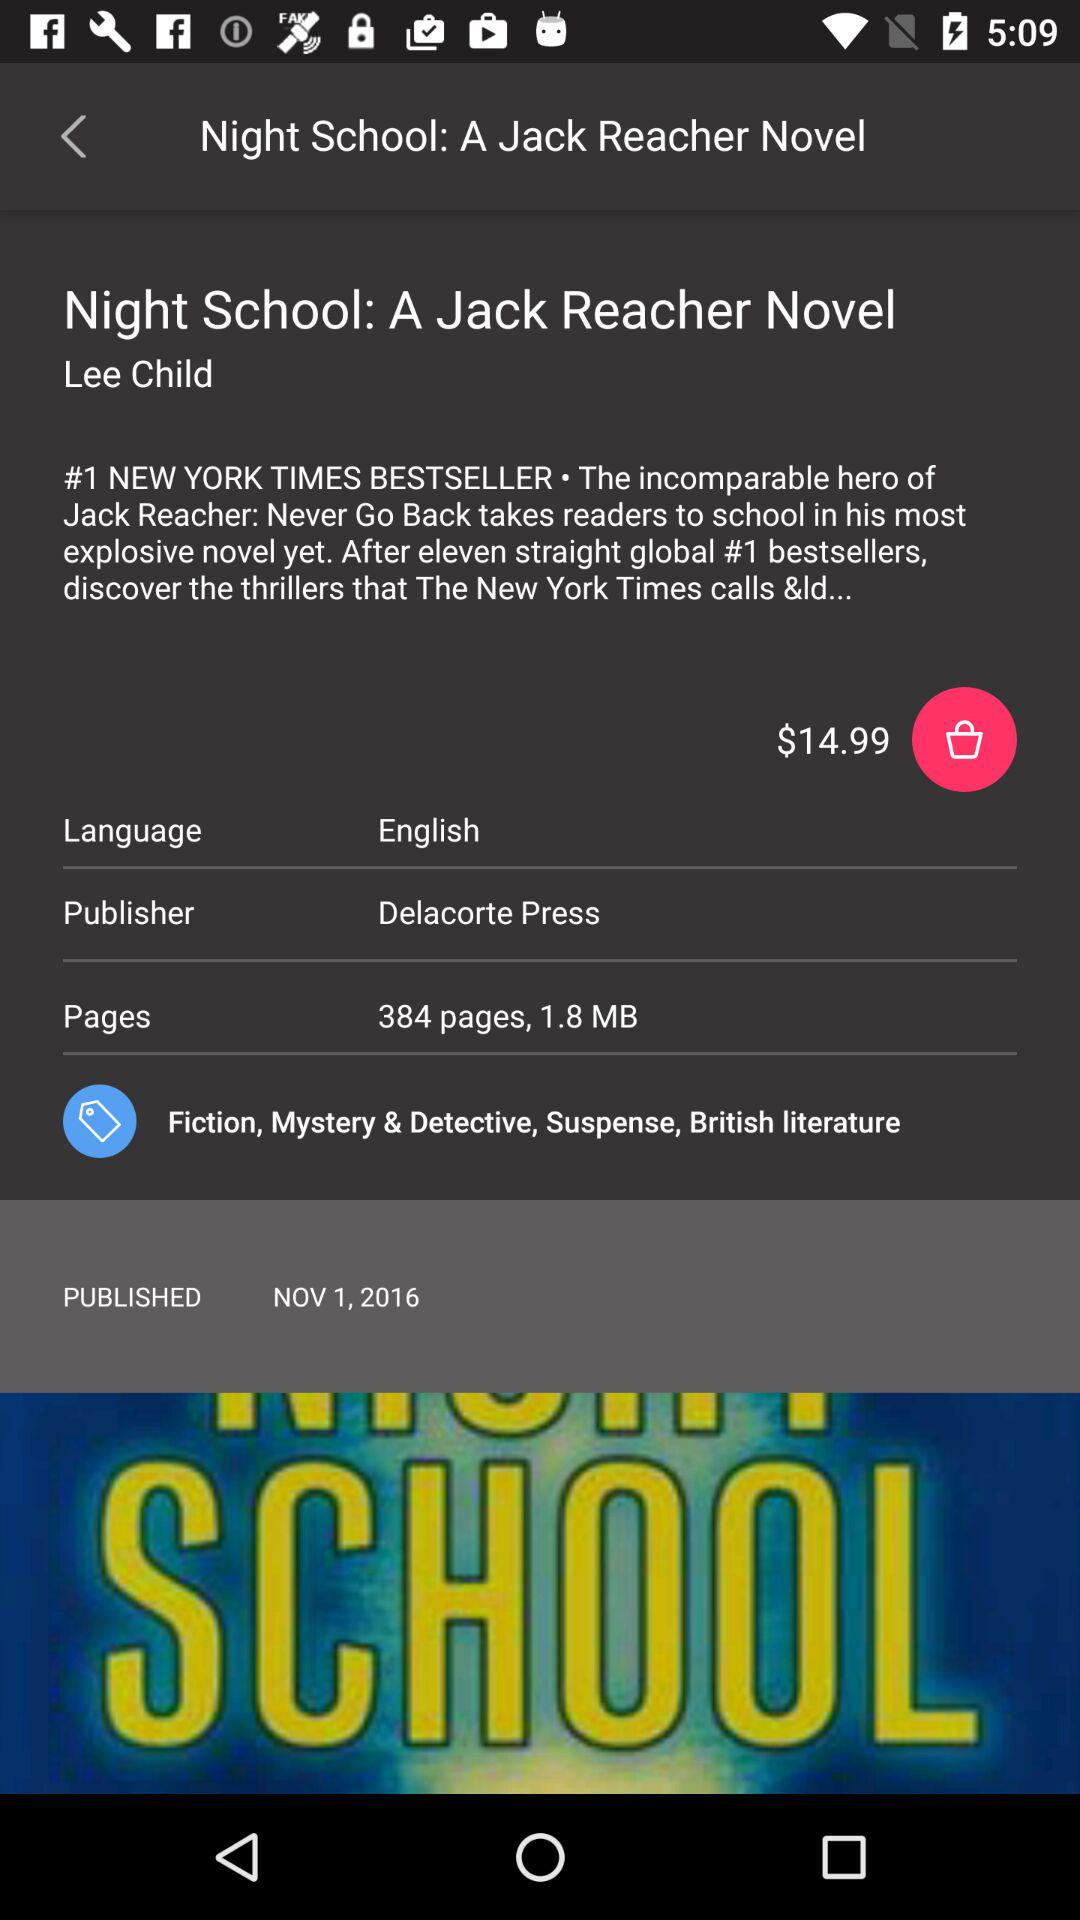When was the novel published? The novel was published on November 1, 2016. 